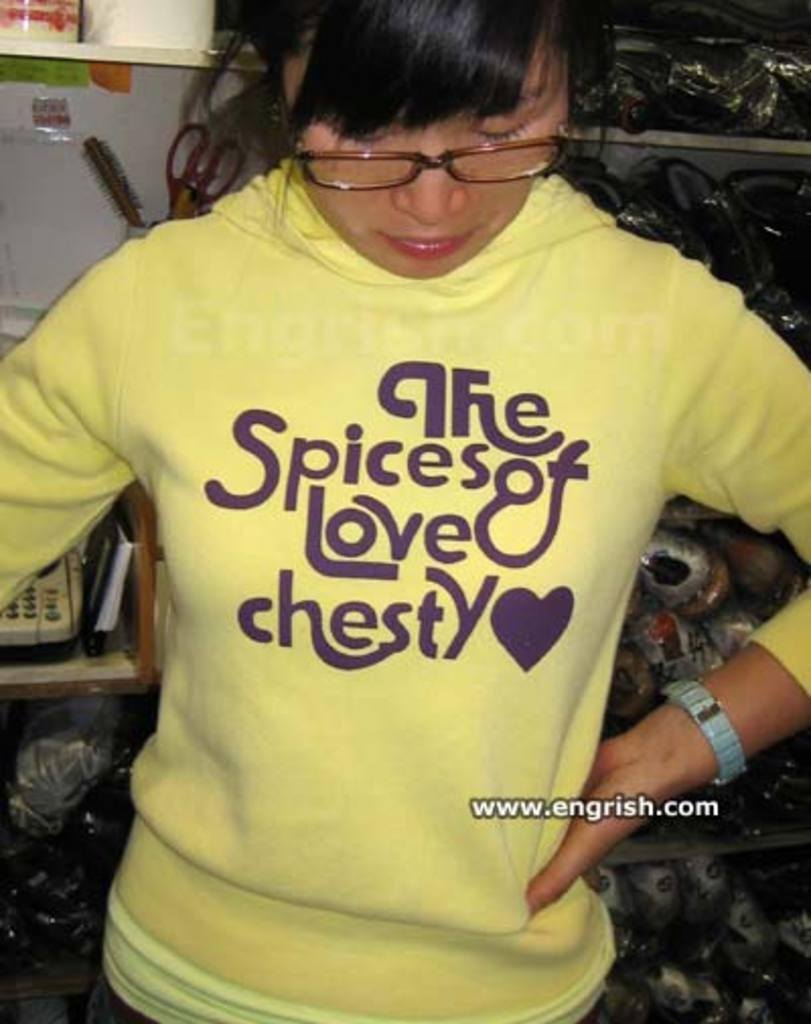Who is present in the image? There is a woman in the image. What is the woman wearing? The woman is wearing a yellow jacket. What can be seen in the background of the image? There are shelves and a toy in the background of the image. What type of payment is being made in the image? There is no payment being made in the image; it features a woman wearing a yellow jacket with shelves and a toy in the background. 